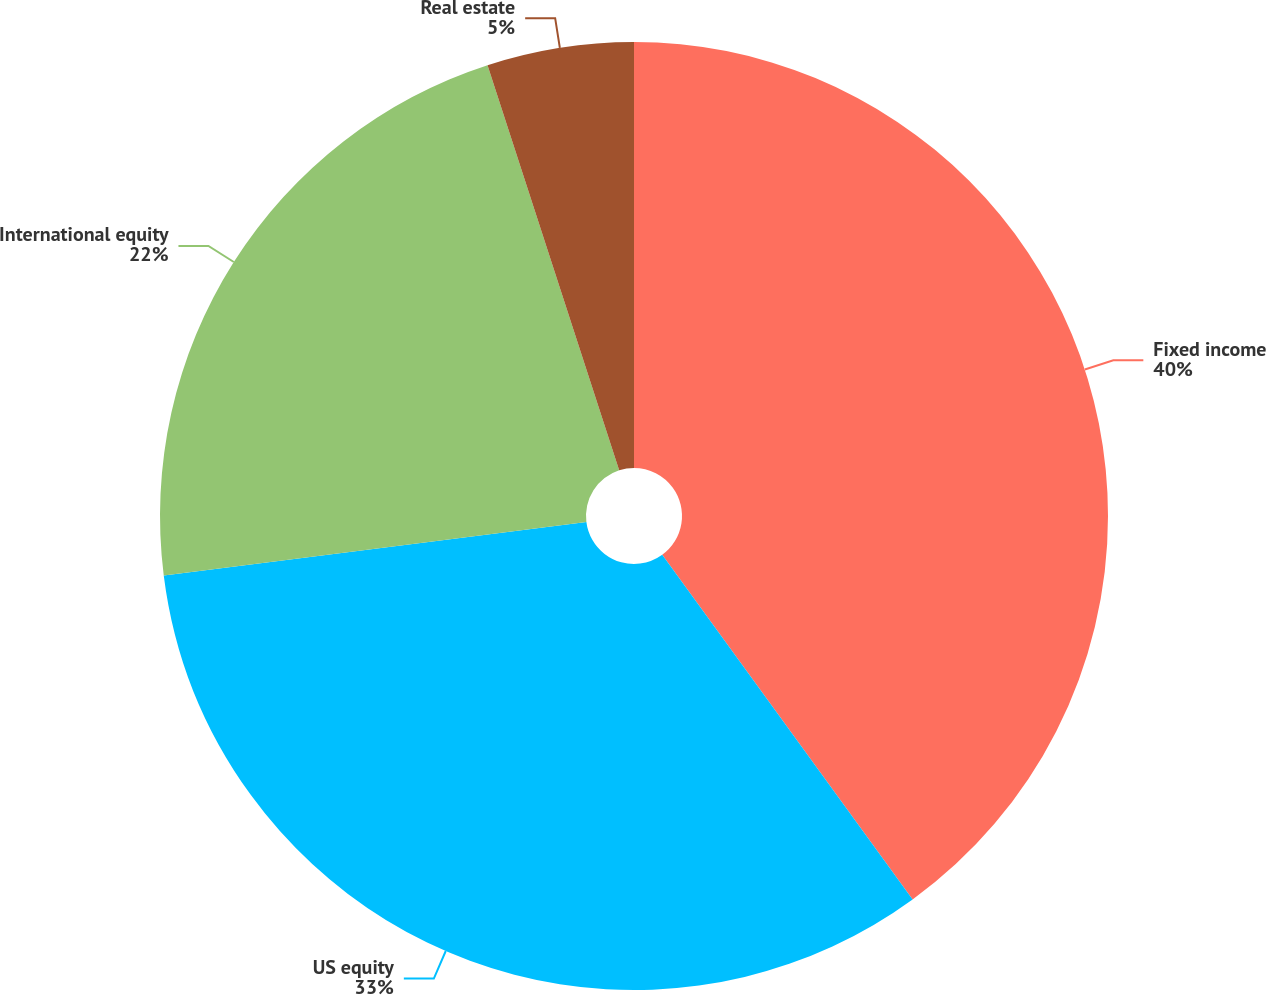Convert chart to OTSL. <chart><loc_0><loc_0><loc_500><loc_500><pie_chart><fcel>Fixed income<fcel>US equity<fcel>International equity<fcel>Real estate<nl><fcel>40.0%<fcel>33.0%<fcel>22.0%<fcel>5.0%<nl></chart> 